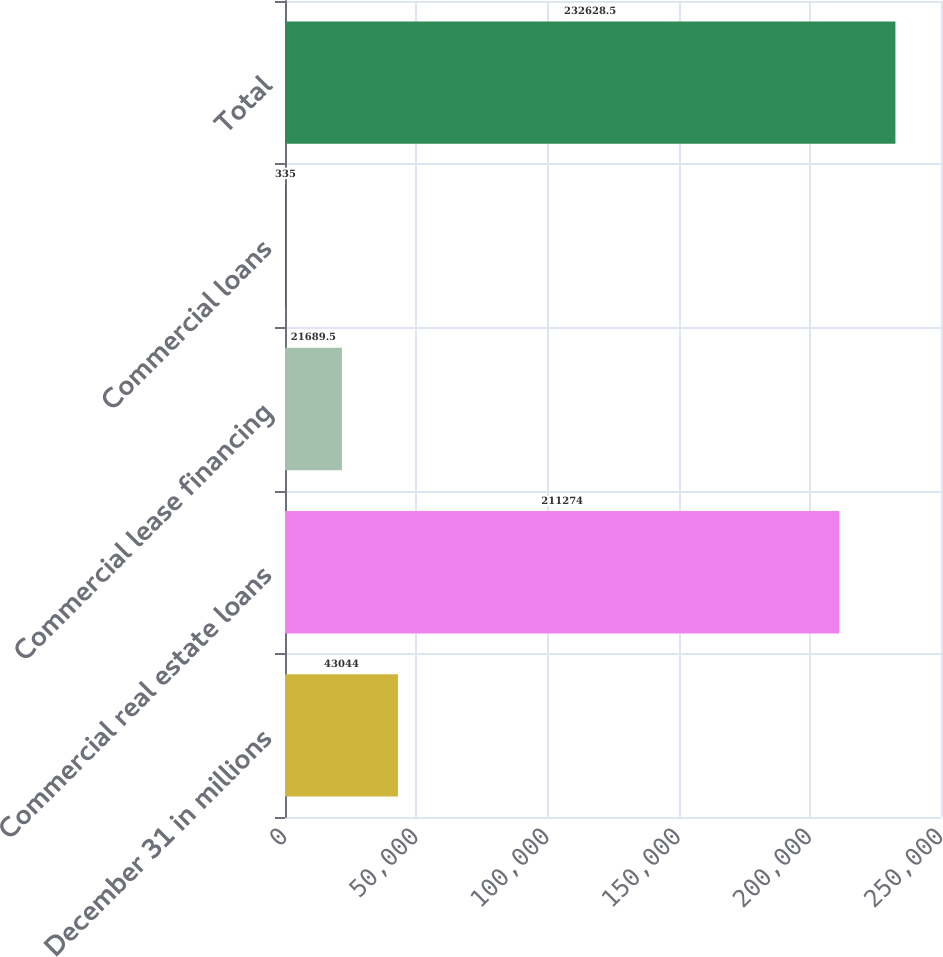Convert chart. <chart><loc_0><loc_0><loc_500><loc_500><bar_chart><fcel>December 31 in millions<fcel>Commercial real estate loans<fcel>Commercial lease financing<fcel>Commercial loans<fcel>Total<nl><fcel>43044<fcel>211274<fcel>21689.5<fcel>335<fcel>232628<nl></chart> 